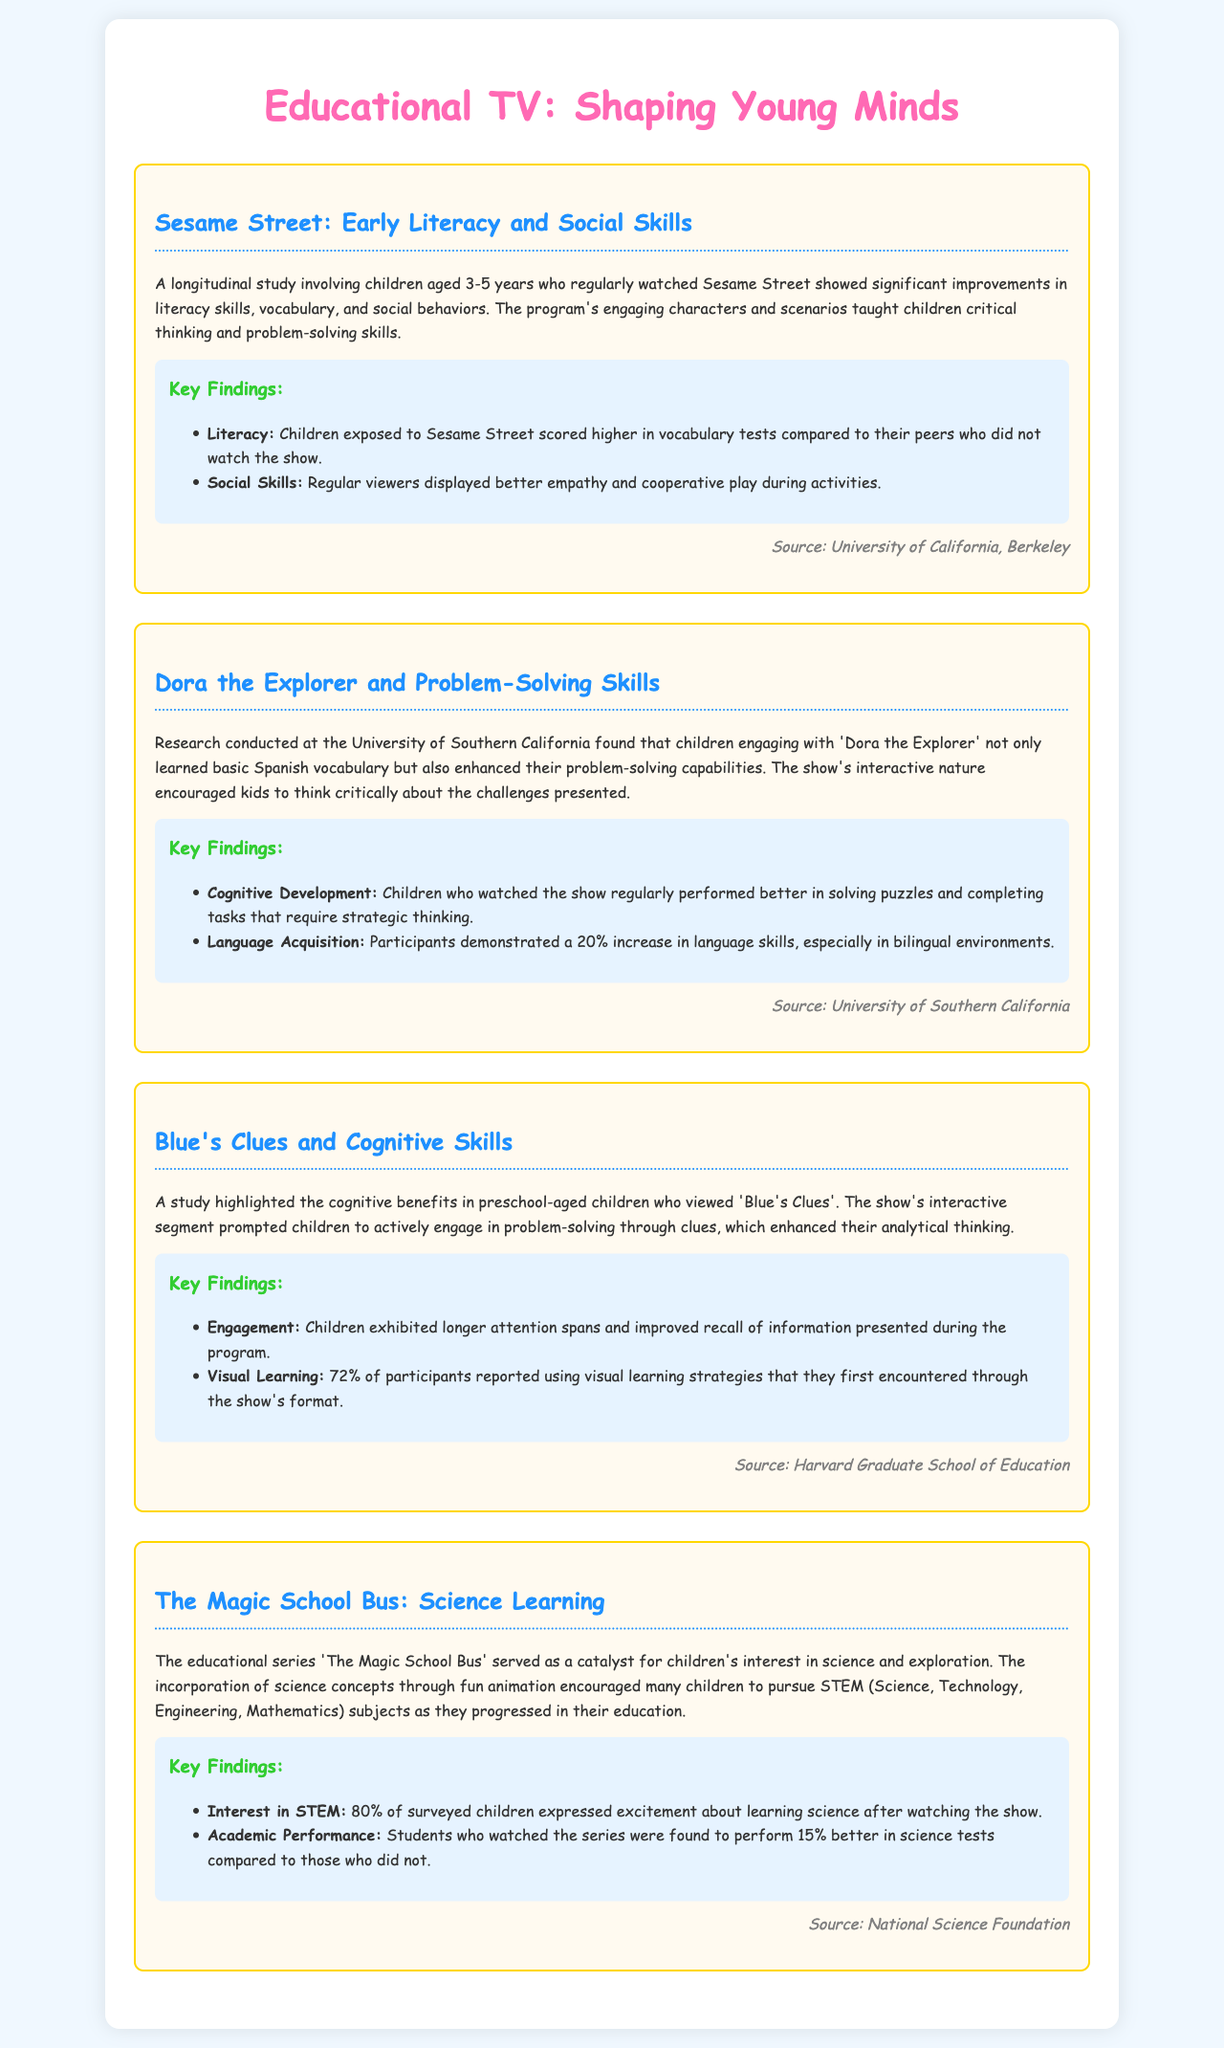What is the title of the report? The title of the report is stated in the header of the document, which identifies the main focus of the content.
Answer: Educational TV: Shaping Young Minds Which show is associated with early literacy and social skills? The case study section describes the program that focuses on early literacy and social skills in children.
Answer: Sesame Street What percentage of children expressed excitement about learning science from The Magic School Bus? The key findings regarding children's excitement about science after watching the show are highlighted in the case study.
Answer: 80% What was the improvement in vocabulary tests for children who watched Sesame Street? The document mentions a specific benefit these children experienced related to vocabulary skills.
Answer: Higher What source is cited for the benefits of watching Dora the Explorer? Each case study cites a research source that provides credibility to the findings presented.
Answer: University of Southern California How much did children enhance their problem-solving capabilities while watching Dora the Explorer? The document specifically states the cognitive outcomes related to problem-solving abilities from watching the show.
Answer: Enhanced What is the cognitive benefit highlighted for Blue's Clues? The findings section for Blue's Clues discusses improvements noticed in children viewing the program, particularly in cognitive skills.
Answer: Analytical thinking Which age group was involved in the Sesame Street study? The document specifies the age range of children participating in the longitudinal study related to Sesame Street.
Answer: 3-5 years 